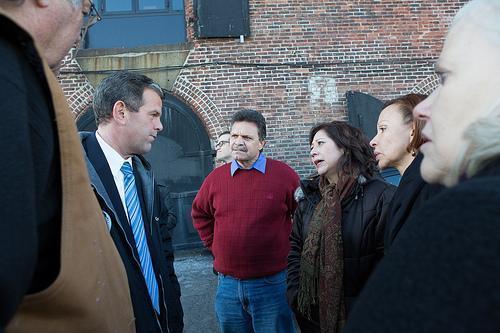How many people wear glasses?
Give a very brief answer. 2. 